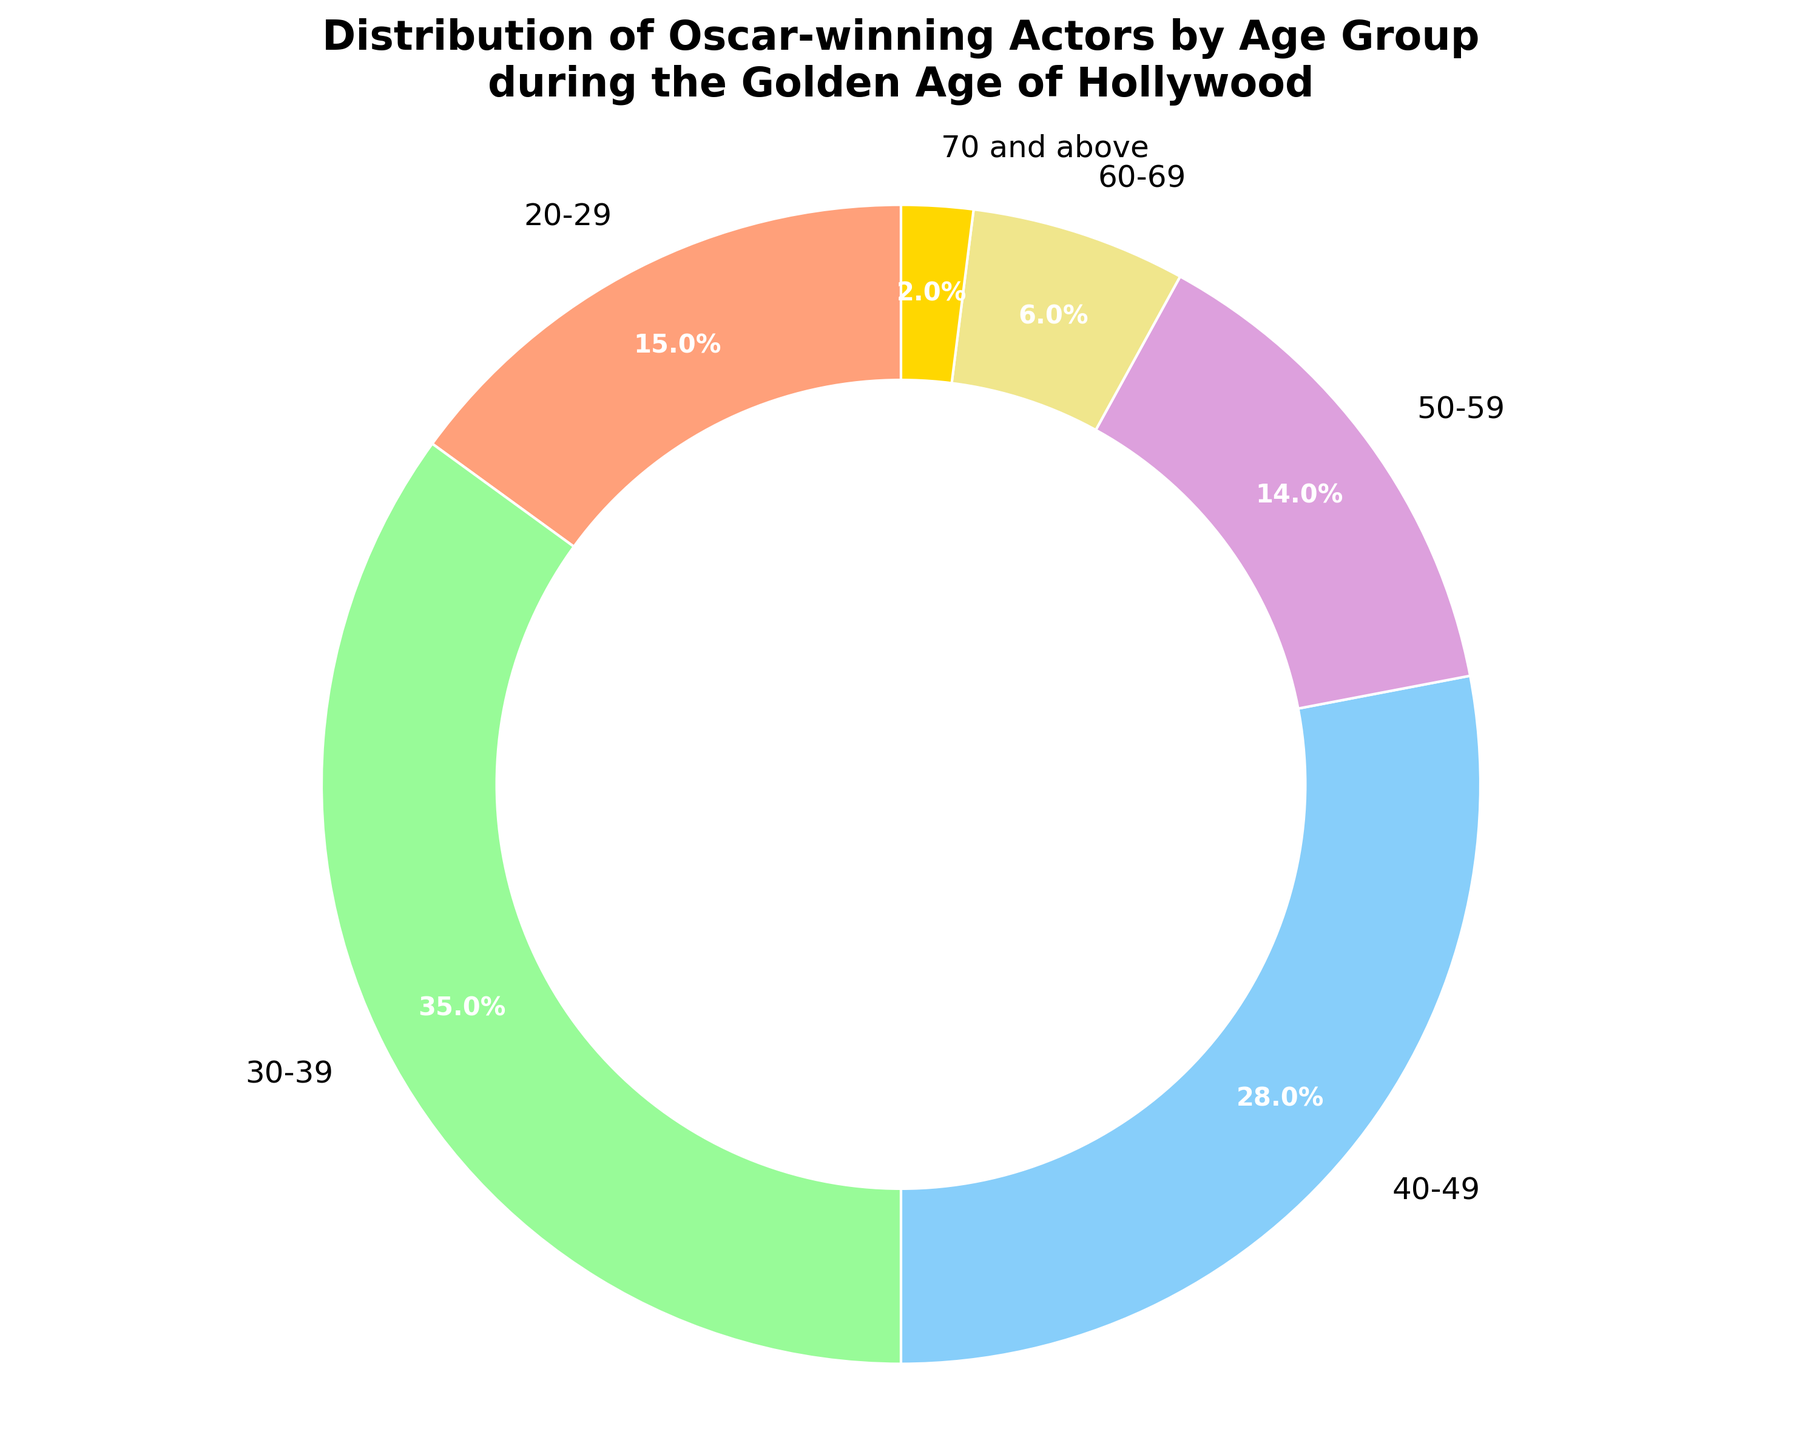What's the largest age group of Oscar-winning actors during the Golden Age of Hollywood? The figure shows various age groups with their respective percentages. The largest slice represents the age group 30-39, which has the highest percentage of 35%.
Answer: 30-39 Which age group of Oscar-winning actors had the smallest representation during the Golden Age of Hollywood? From the visual display, the smallest slice corresponds to the age group 70 and above, with a percentage of 2%.
Answer: 70 and above How do the combined percentages of actors aged 50 and above compare to those aged 40-49? Summing the percentages: 50-59 (14%) + 60-69 (6%) + 70 and above (2%) equals 22%. Compared to the 40-49 age group, which is 28%, the older age groups are less represented.
Answer: 22% < 28% What visual attribute distinguishes the age group 30-39 among other groups in the pie chart? The age group 30-39 is visually distinguished by the largest segment of the pie chart, indicating it has the highest percentage at 35%. It also typically has its position starting near the top or most prominent part due to the start angle.
Answer: Largest segment at 35% If you combine the age groups 20-29 and 30-39, what proportion of the total do they represent? The percentages for 20-29 and 30-39 are 15% and 35%, respectively. Adding them gives 15% + 35% = 50%. So, half of all Oscar-winning actors during the Golden Age of Hollywood were in these two age groups.
Answer: 50% Which age group had a nearly equal representation to the 20-29 age group? The 20-29 age group is represented by 15%. The 50-59 age group, represented by 14%, is nearly equal to it.
Answer: 50-59 Considering the percentages, which color would you look for on the pie chart if you want to find the age group 60-69? Since each age group is represented by a specific color in the pie chart, and the given explanation points to an attribute of the visual chart, you would need to reference the corresponding light yellow segment since it represents 60-69 at 6%.
Answer: Light yellow segment What differentiates the percentages of actors aged 40-49 and 50-59 visually? The pie segment for 40-49 is notably larger than the segment for 50-59. The 40-49 group's slice is more than double the size of 50-59, representing 28% compared to 14%.
Answer: Larger slice for 40-49 What's the combined percentage of the youngest and the oldest age groups? Summing the percentages for the youngest (20-29, 15%) and the oldest age group (70 and above, 2%) gives a total of 15% + 2% = 17%.
Answer: 17% 